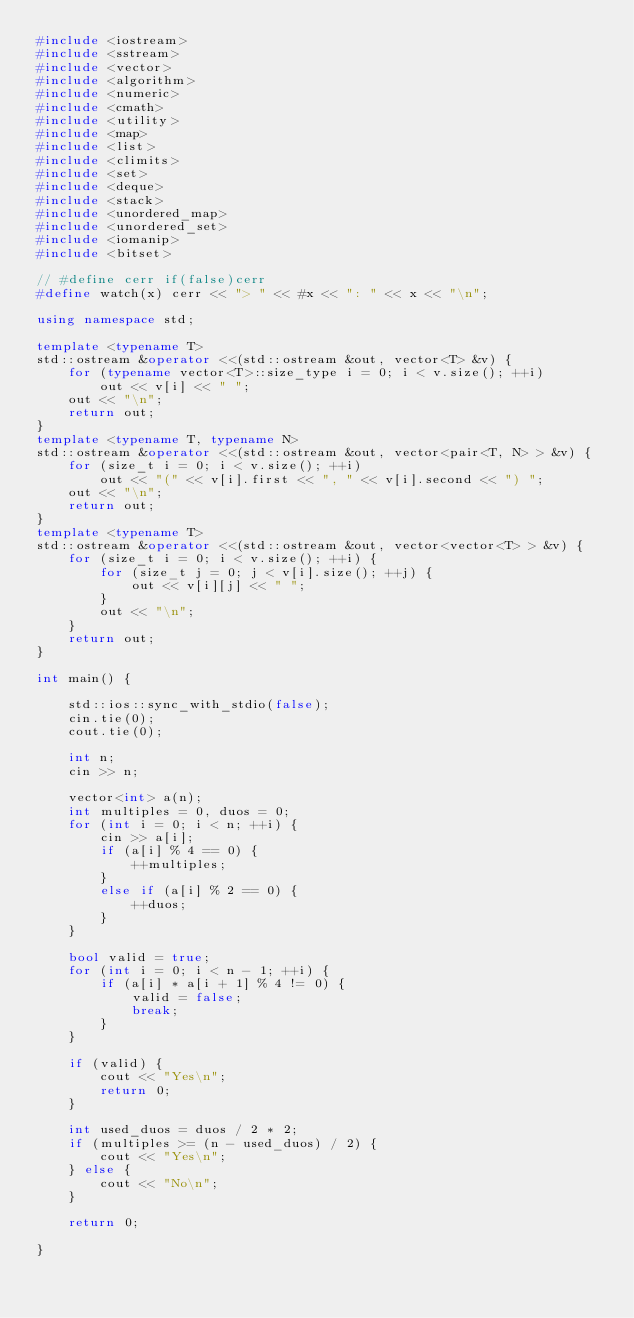<code> <loc_0><loc_0><loc_500><loc_500><_C++_>#include <iostream>
#include <sstream>
#include <vector>
#include <algorithm>
#include <numeric>
#include <cmath>
#include <utility>
#include <map>
#include <list>
#include <climits>
#include <set>
#include <deque>
#include <stack>
#include <unordered_map>
#include <unordered_set>
#include <iomanip>
#include <bitset>

// #define cerr if(false)cerr
#define watch(x) cerr << "> " << #x << ": " << x << "\n";

using namespace std;

template <typename T>
std::ostream &operator <<(std::ostream &out, vector<T> &v) {
	for (typename vector<T>::size_type i = 0; i < v.size(); ++i)
		out << v[i] << " ";
	out << "\n";
    return out;
}
template <typename T, typename N>
std::ostream &operator <<(std::ostream &out, vector<pair<T, N> > &v) {
	for (size_t i = 0; i < v.size(); ++i)
		out << "(" << v[i].first << ", " << v[i].second << ") ";
	out << "\n";
    return out;
}
template <typename T>
std::ostream &operator <<(std::ostream &out, vector<vector<T> > &v) {
	for (size_t i = 0; i < v.size(); ++i) {
		for (size_t j = 0; j < v[i].size(); ++j) {
			out << v[i][j] << " ";
		}
		out << "\n";
	}
   	return out;
}

int main() {

	std::ios::sync_with_stdio(false);
	cin.tie(0);
	cout.tie(0);

	int n;
	cin >> n;

	vector<int> a(n);
	int multiples = 0, duos = 0;
	for (int i = 0; i < n; ++i) {
		cin >> a[i];
		if (a[i] % 4 == 0) {
			++multiples;
		}
		else if (a[i] % 2 == 0) {
			++duos;
		}
	}

	bool valid = true;
	for (int i = 0; i < n - 1; ++i) {
		if (a[i] * a[i + 1] % 4 != 0) {
			valid = false;
			break;
		}
	}

	if (valid) {
		cout << "Yes\n";
		return 0;
	}

	int used_duos = duos / 2 * 2;
	if (multiples >= (n - used_duos) / 2) {
		cout << "Yes\n";
	} else {
		cout << "No\n";
	}

	return 0;

}</code> 